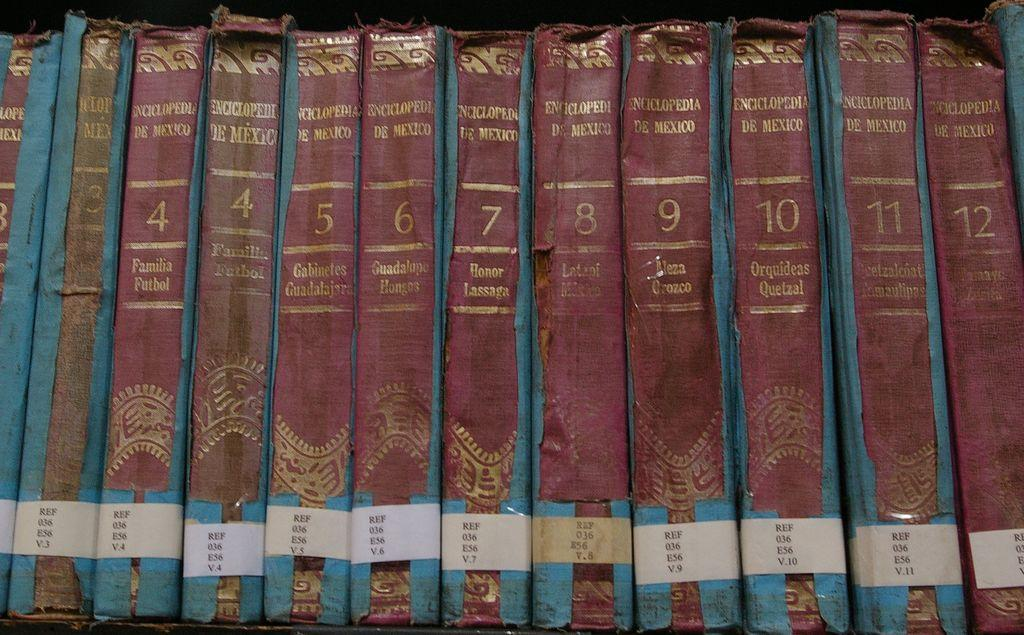What can be seen in the image that is used for storage? There is a shelf in the image that is used for storage. What items are stored on the shelf? There are many books on the shelf. How are the books arranged on the shelf? The books are arranged in a row on the shelf. What type of pump can be seen in the image? There is no pump present in the image; it features a shelf with books arranged in a row. 